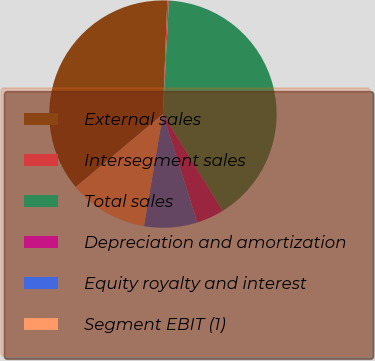<chart> <loc_0><loc_0><loc_500><loc_500><pie_chart><fcel>External sales<fcel>Intersegment sales<fcel>Total sales<fcel>Depreciation and amortization<fcel>Equity royalty and interest<fcel>Segment EBIT (1)<nl><fcel>36.7%<fcel>0.23%<fcel>40.37%<fcel>3.9%<fcel>7.57%<fcel>11.24%<nl></chart> 